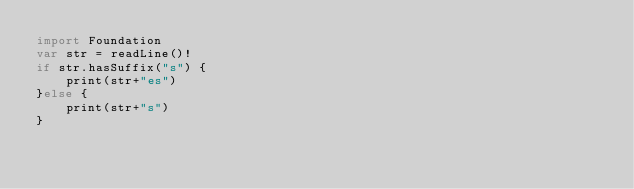Convert code to text. <code><loc_0><loc_0><loc_500><loc_500><_Swift_>import Foundation
var str = readLine()!
if str.hasSuffix("s") {
    print(str+"es")
}else {
    print(str+"s")
}</code> 